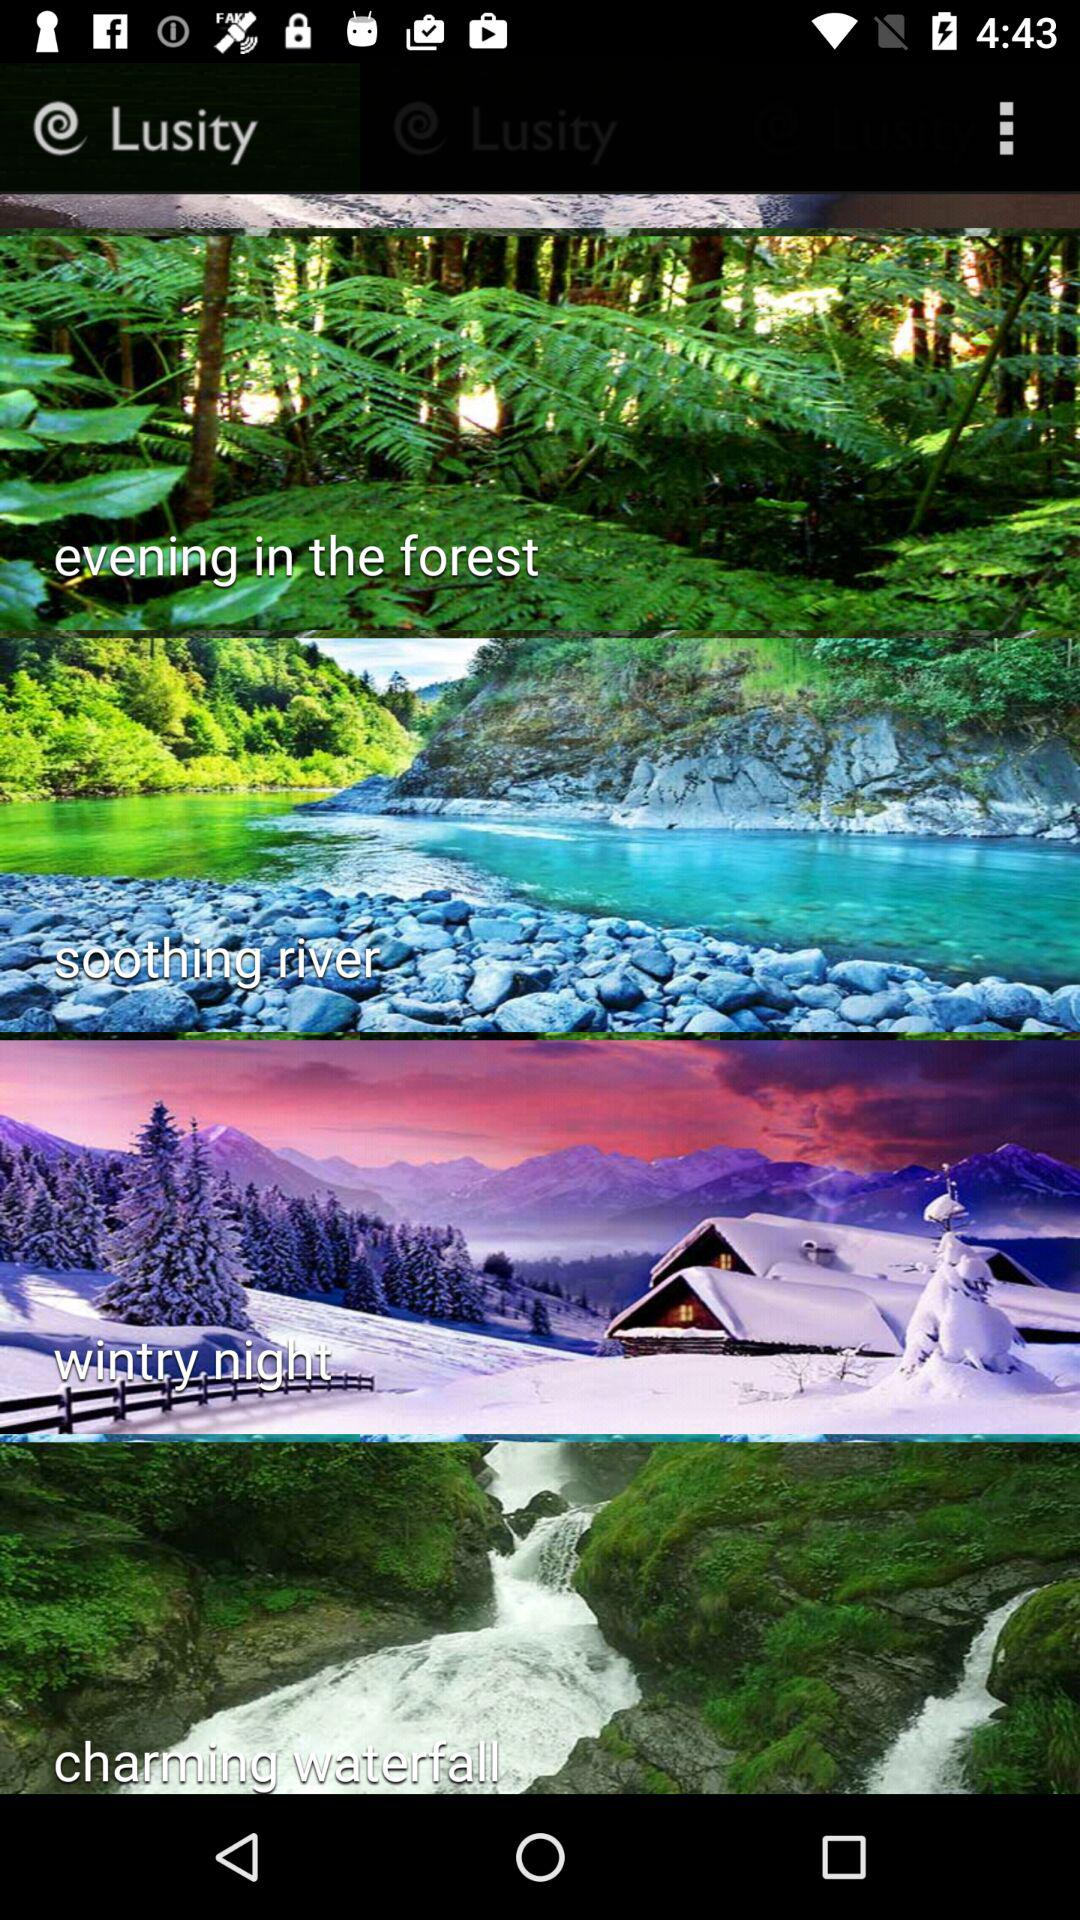What is the application name? The application name is "Lusity". 